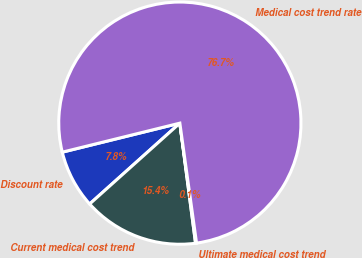<chart> <loc_0><loc_0><loc_500><loc_500><pie_chart><fcel>Discount rate<fcel>Current medical cost trend<fcel>Ultimate medical cost trend<fcel>Medical cost trend rate<nl><fcel>7.78%<fcel>15.44%<fcel>0.13%<fcel>76.65%<nl></chart> 